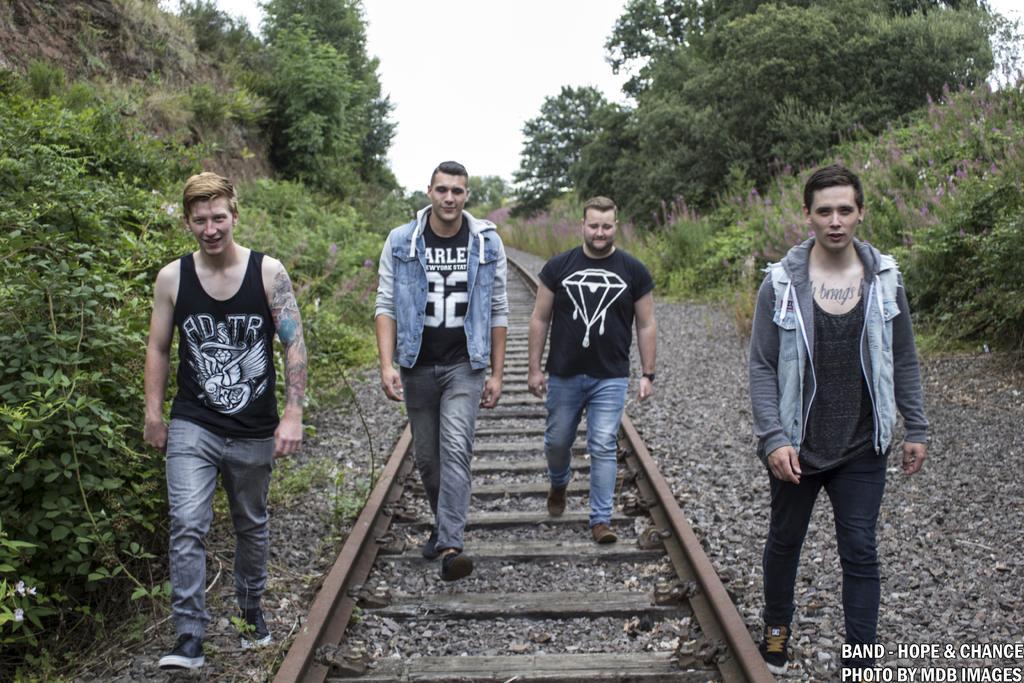Can you describe this image briefly? In this image there are four men walking on the tracks and stones, at the bottom of the image there is text, behind them there are plants and trees. 